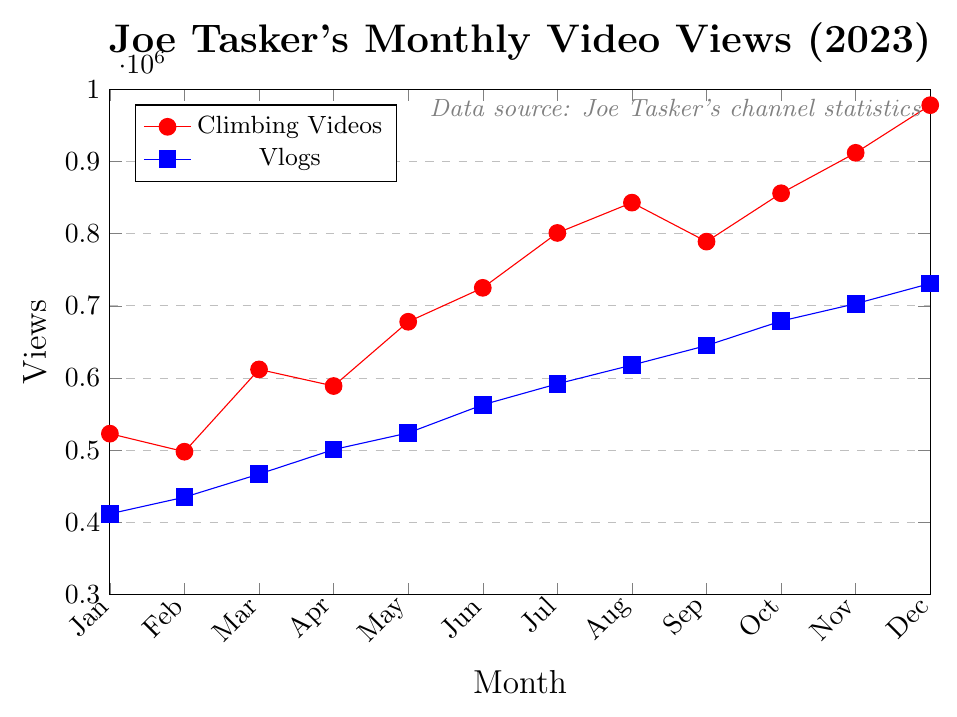What's the trend in the views of Joe Tasker's climbing videos over the year? The climbing videos show a generally increasing trend in views over the months. Starting from 523,000 views in January to 978,000 views in December, the views consistently rise with only minor fluctuations.
Answer: Increasing What's the difference in views between Joe Tasker's climbing videos and vlogs in October 2023? In October 2023, the views for climbing videos are 856,000 and for vlogs, it's 679,000. The difference is calculated as 856,000 - 679,000.
Answer: 177,000 Which month saw the highest number of views for Joe Tasker's vlogs? The highest number of vlog views appears in December 2023, where the views are 731,000. By comparing the data for each month, it is clear that December has the highest value.
Answer: December 2023 Compare the views of vlogs and climbing videos in March 2023. Which had more views and by how much? In March 2023, the views for climbing videos were 612,000 and vlogs were 467,000. Climbing videos had more views, calculated as 612,000 - 467,000.
Answer: Climbing videos by 145,000 views What is the average monthly viewership of Joe Tasker's vlogs in 2023? To find the monthly average, sum up all the monthly vlog views and then divide by 12. The sum is 412,000 + 435,000 + 467,000 + 501,000 + 524,000 + 563,000 + 592,000 + 618,000 + 645,000 + 679,000 + 703,000 + 731,000 = 6,870,000. The average is 6,870,000 / 12.
Answer: 572,500 By how much did the viewership of Joe Tasker's climbing videos increase from January to December 2023? The viewership for climbing videos in January is 523,000 and in December is 978,000. The increase is 978,000 - 523,000.
Answer: 455,000 In which month was the viewership of climbing videos the lowest? The lowest viewership for climbing videos is found in February 2023 with 498,000 views.
Answer: February 2023 What is the combined viewership of both video types in July 2023? To find the combined viewership, add the views for climbing videos and vlogs in July 2023. Climbing videos have 801,000 views and vlogs have 592,000 views. The combined total is 801,000 + 592,000.
Answer: 1,393,000 Which type of video consistently attracted more views throughout the year? By comparing the monthly data, it's evident that climbing videos consistently attracted more views than vlogs every month of the year.
Answer: Climbing videos How do the viewership trends of climbing videos and vlogs compare over the year? Both the climbing videos and vlogs show an increasing trend over the year. However, the climbing videos have a sharper increase in views and higher values each month compared to the vlogs.
Answer: Climbing videos have a sharper increase and higher values 